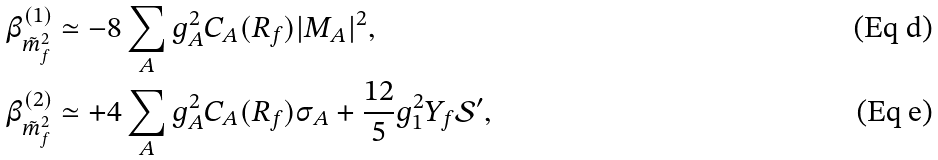<formula> <loc_0><loc_0><loc_500><loc_500>\beta ^ { ( 1 ) } _ { \tilde { m } ^ { 2 } _ { f } } & \simeq - 8 \sum _ { A } g _ { A } ^ { 2 } C _ { A } ( R _ { f } ) | M _ { A } | ^ { 2 } , \\ \beta ^ { ( 2 ) } _ { \tilde { m } ^ { 2 } _ { f } } & \simeq + 4 \sum _ { A } g _ { A } ^ { 2 } C _ { A } ( R _ { f } ) \sigma _ { A } + \frac { 1 2 } { 5 } g _ { 1 } ^ { 2 } Y _ { f } { \mathcal { S } } ^ { \prime } ,</formula> 